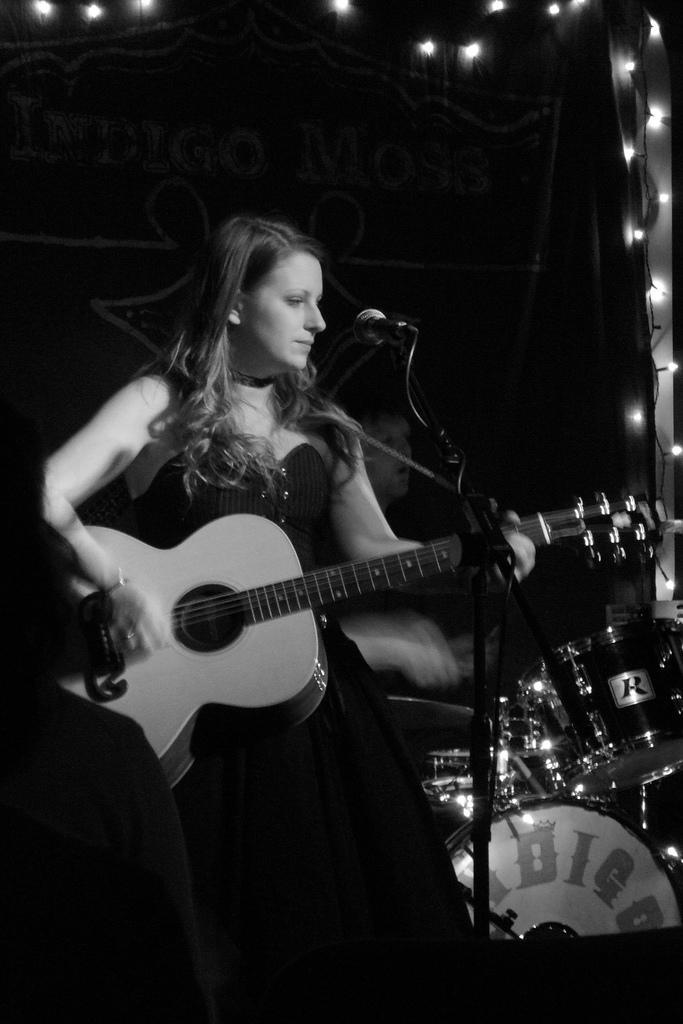Can you describe this image briefly? In this image I can see a person standing in front of the mic and playing the guitar. To the left of her there is a drum set. 